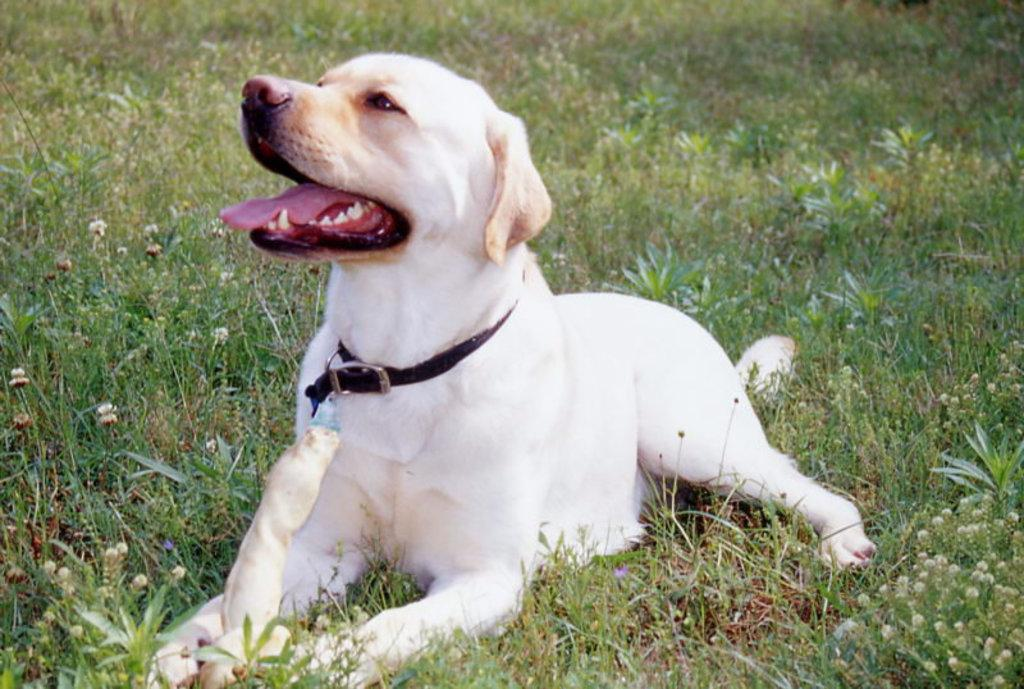Where was the picture taken? The picture was taken outside. What can be seen sitting on the ground in the image? There is a dog sitting on the ground in the image. What type of vegetation is present in the image? There is green grass, plants, and flowers in the image. Can you see a giraffe grazing on the flowers in the image? No, there is no giraffe present in the image. Are there any light bulbs visible in the image? There are no light bulbs mentioned or visible in the image. 